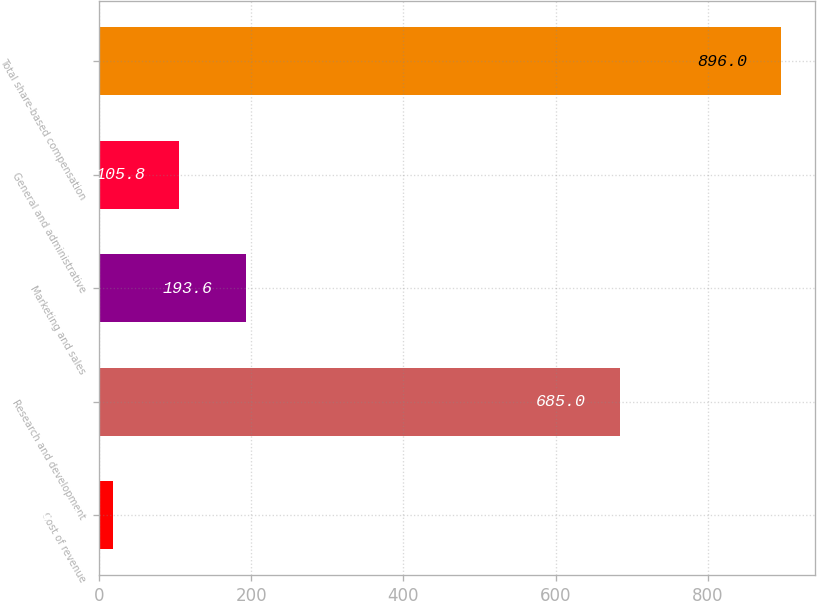<chart> <loc_0><loc_0><loc_500><loc_500><bar_chart><fcel>Cost of revenue<fcel>Research and development<fcel>Marketing and sales<fcel>General and administrative<fcel>Total share-based compensation<nl><fcel>18<fcel>685<fcel>193.6<fcel>105.8<fcel>896<nl></chart> 